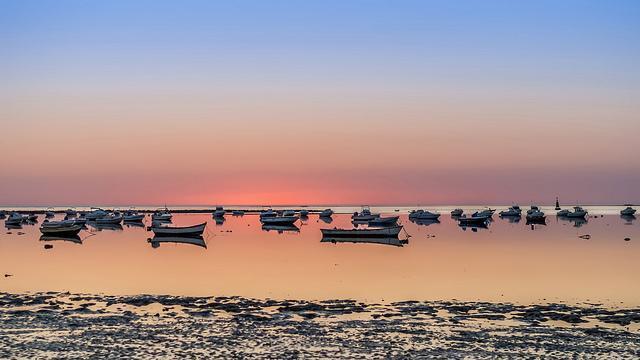How many people is the elephant interacting with?
Give a very brief answer. 0. 